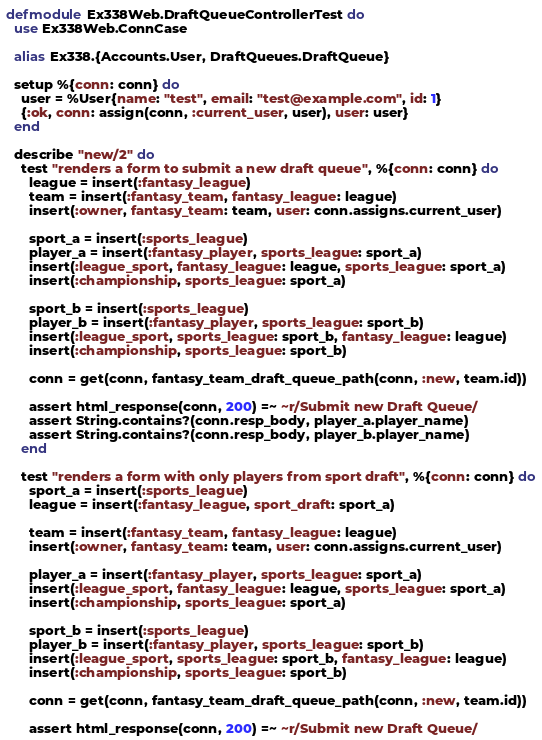<code> <loc_0><loc_0><loc_500><loc_500><_Elixir_>defmodule Ex338Web.DraftQueueControllerTest do
  use Ex338Web.ConnCase

  alias Ex338.{Accounts.User, DraftQueues.DraftQueue}

  setup %{conn: conn} do
    user = %User{name: "test", email: "test@example.com", id: 1}
    {:ok, conn: assign(conn, :current_user, user), user: user}
  end

  describe "new/2" do
    test "renders a form to submit a new draft queue", %{conn: conn} do
      league = insert(:fantasy_league)
      team = insert(:fantasy_team, fantasy_league: league)
      insert(:owner, fantasy_team: team, user: conn.assigns.current_user)

      sport_a = insert(:sports_league)
      player_a = insert(:fantasy_player, sports_league: sport_a)
      insert(:league_sport, fantasy_league: league, sports_league: sport_a)
      insert(:championship, sports_league: sport_a)

      sport_b = insert(:sports_league)
      player_b = insert(:fantasy_player, sports_league: sport_b)
      insert(:league_sport, sports_league: sport_b, fantasy_league: league)
      insert(:championship, sports_league: sport_b)

      conn = get(conn, fantasy_team_draft_queue_path(conn, :new, team.id))

      assert html_response(conn, 200) =~ ~r/Submit new Draft Queue/
      assert String.contains?(conn.resp_body, player_a.player_name)
      assert String.contains?(conn.resp_body, player_b.player_name)
    end

    test "renders a form with only players from sport draft", %{conn: conn} do
      sport_a = insert(:sports_league)
      league = insert(:fantasy_league, sport_draft: sport_a)

      team = insert(:fantasy_team, fantasy_league: league)
      insert(:owner, fantasy_team: team, user: conn.assigns.current_user)

      player_a = insert(:fantasy_player, sports_league: sport_a)
      insert(:league_sport, fantasy_league: league, sports_league: sport_a)
      insert(:championship, sports_league: sport_a)

      sport_b = insert(:sports_league)
      player_b = insert(:fantasy_player, sports_league: sport_b)
      insert(:league_sport, sports_league: sport_b, fantasy_league: league)
      insert(:championship, sports_league: sport_b)

      conn = get(conn, fantasy_team_draft_queue_path(conn, :new, team.id))

      assert html_response(conn, 200) =~ ~r/Submit new Draft Queue/</code> 